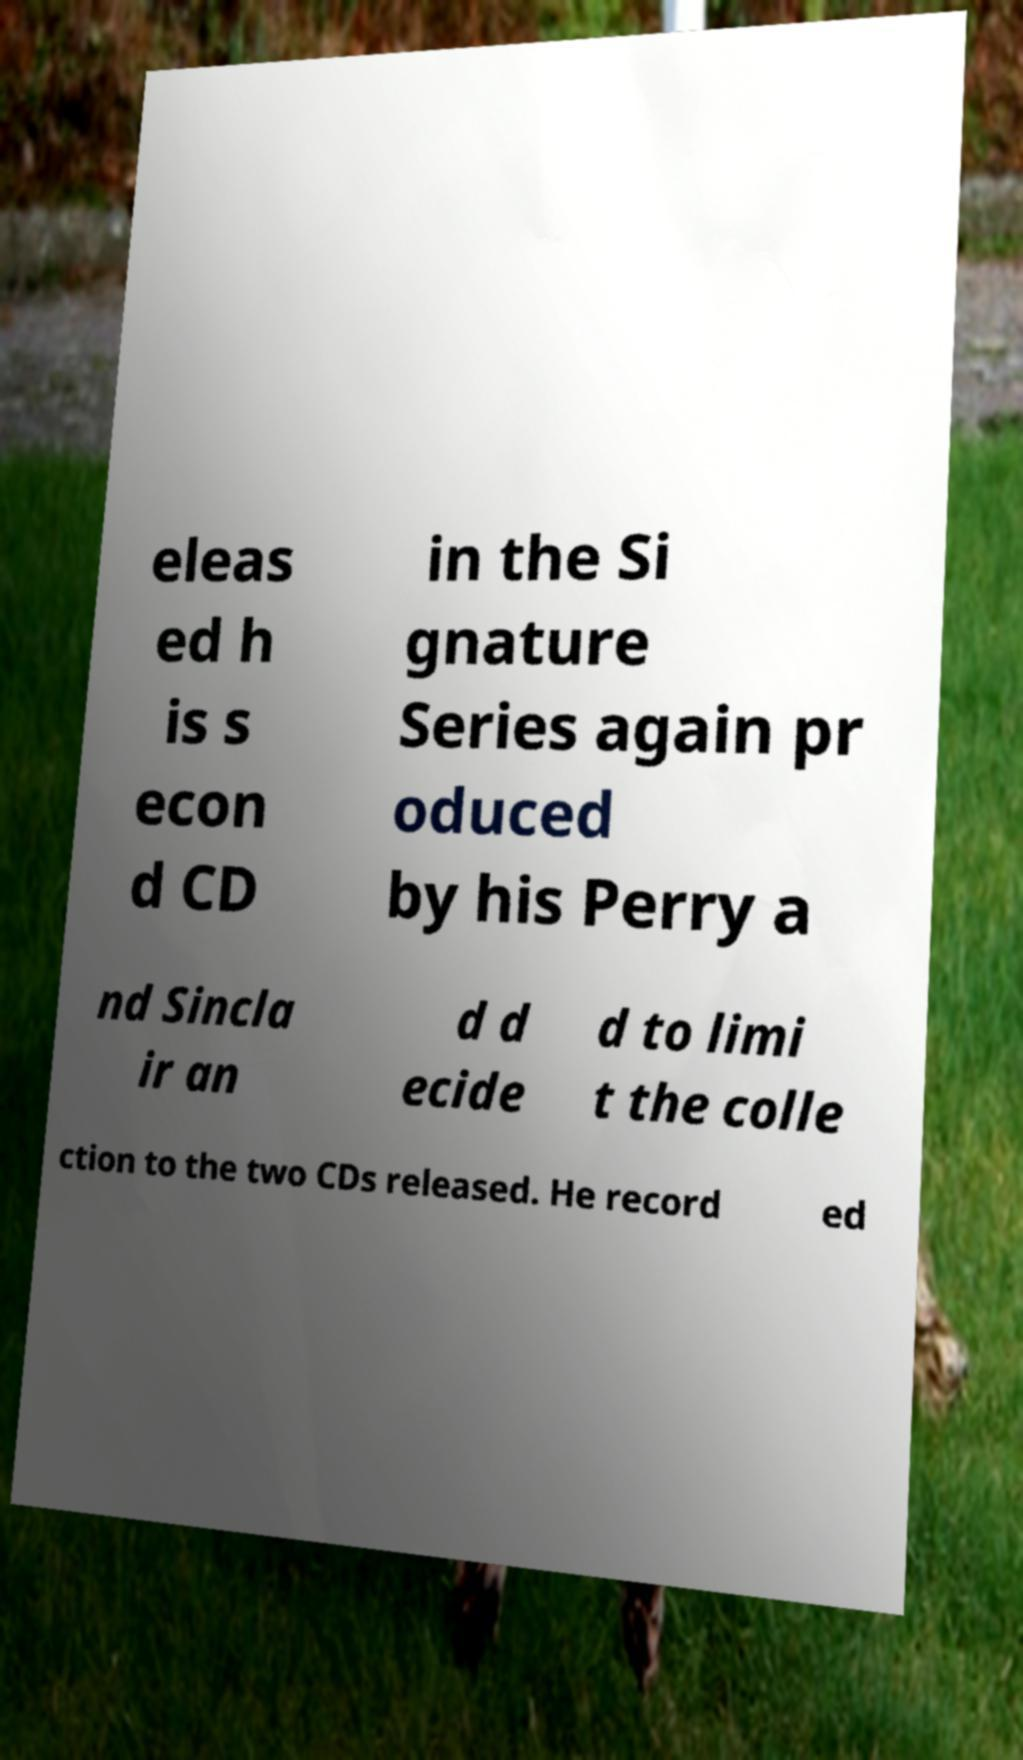Can you read and provide the text displayed in the image?This photo seems to have some interesting text. Can you extract and type it out for me? eleas ed h is s econ d CD in the Si gnature Series again pr oduced by his Perry a nd Sincla ir an d d ecide d to limi t the colle ction to the two CDs released. He record ed 